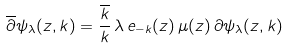Convert formula to latex. <formula><loc_0><loc_0><loc_500><loc_500>\overline { \partial } \psi _ { \lambda } ( z , k ) = \frac { \overline { k } } { k } \, \lambda \, e _ { - k } ( z ) \, \mu ( z ) \, { \partial \psi _ { \lambda } ( z , k ) }</formula> 